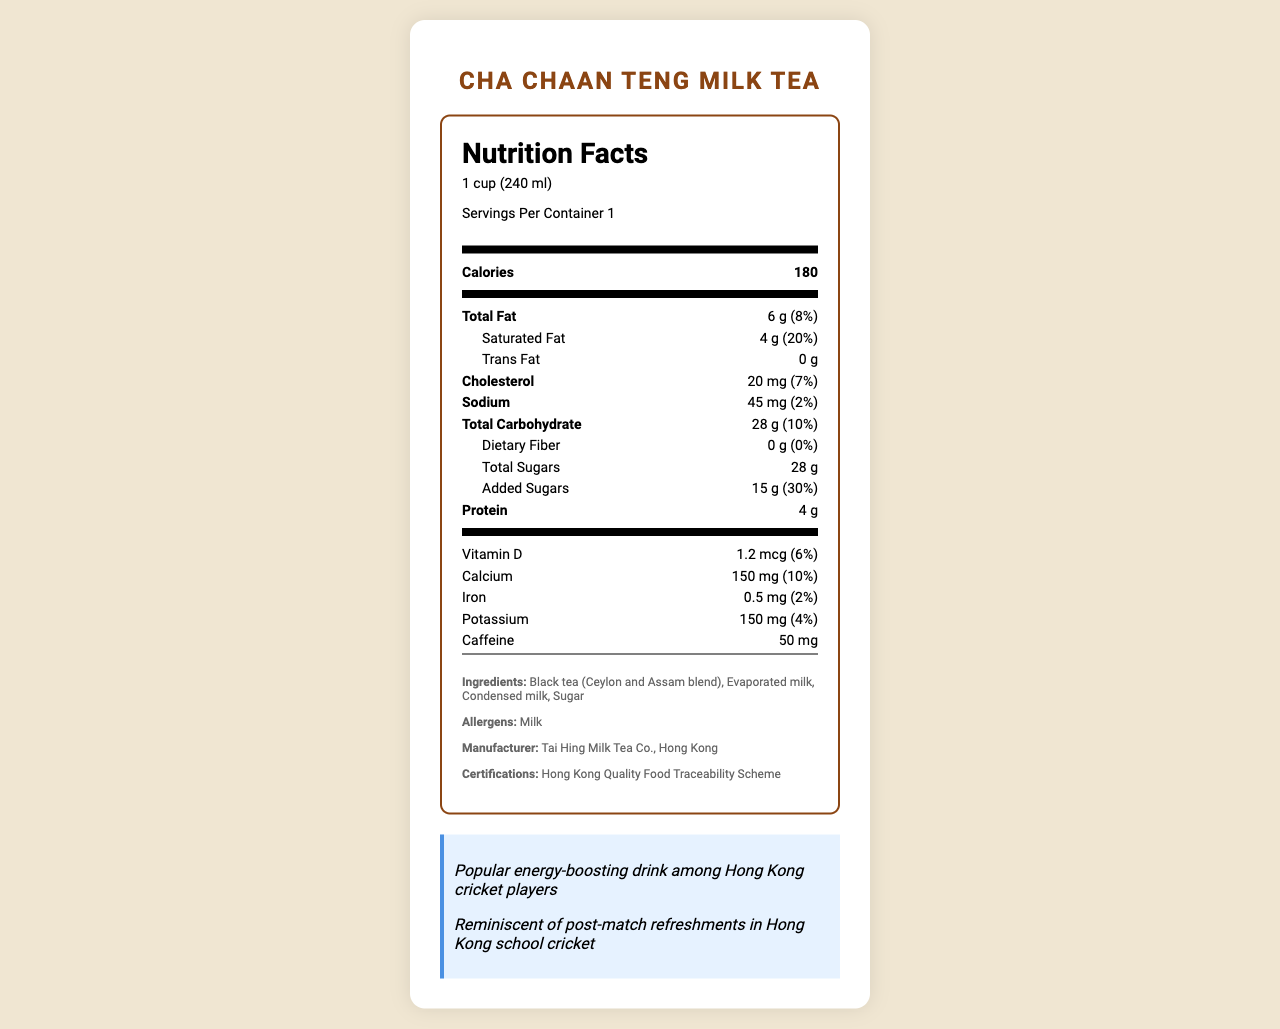what is the serving size of the Cha Chaan Teng Milk Tea? The serving size is displayed right under the product name at the top of the nutrition label.
Answer: 1 cup (240 ml) how many calories are there per serving? The number of calories per serving is listed in bold directly below the serving information.
Answer: 180 what percentage of the daily value does the Total Fat content represent? Below the Total Fat amount of 6 g, the percentage daily value is given as 8%.
Answer: 8% what is the amount of added sugars per serving? The amount of added sugars is listed as 15 g in the indentation under Total Sugars.
Answer: 15 g what is the potassium content in milligrams? The potassium content is stated as 150 mg with a 4% daily value on the label.
Answer: 150 mg which ingredient is listed first in the milk tea? The ingredient list starts with "Black tea (Ceylon and Assam blend)" indicating it is the first and major ingredient.
Answer: Black tea (Ceylon and Assam blend) what certification does the product have? A. ISO 9001 B. FDA Approved C. Hong Kong Quality Food Traceability Scheme D. Organic Certified The certifications section lists "Hong Kong Quality Food Traceability Scheme."
Answer: C. Hong Kong Quality Food Traceability Scheme how much caffeine does one serving contain? The caffeine content is indicated as 50 mg at the bottom of the nutrition information panel.
Answer: 50 mg is this product suitable for someone with a milk allergy? The allergens section clearly states "Milk," hence it is not suitable for someone with a milk allergy.
Answer: No how much saturated fat is in one serving, and what percentage of the daily value does it represent? The nutrition label specifies that Saturated Fat is 4 g and its daily value percentage is 20%.
Answer: 4 g, 20% what amount of Vitamin D does one serving contain? A. 0.5 mcg B. 1.2 mcg C. 10 mg D. 2.0 mg The nutrition label lists Vitamin D content as 1.2 mcg.
Answer: B. 1.2 mcg is the total carbohydrate amount higher or lower than the protein amount in one serving? The total carbohydrate amount is 28 g, whereas the protein amount is 4 g.
Answer: Higher what preparation method is noted for its unique texture? The additional info mentions that the traditional "silk stocking" method is used for a smooth texture.
Answer: Traditional 'silk stocking' method summarize the main idea of the document The document is a detailed nutrition label for Cha Chaan Teng Milk Tea, featuring serving size, calorie content, nutritional values, and additional details like ingredients, allergens, manufacturer, and cultural notes.
Answer: The document provides the nutrition facts for Cha Chaan Teng Milk Tea, including serving size, calorie content, and detailed nutritional information. It highlights popular features among Hong Kong cricket players and provides additional cultural significance and preparation details. what is the name of the manufacturer? The additional information section lists the manufacturer as Tai Hing Milk Tea Co., Hong Kong.
Answer: Tai Hing Milk Tea Co., Hong Kong what is the sodium percentage of the daily value, and how much does one serving contribute to it? The nutrition label states that the sodium amount for one serving is 45 mg, which contributes to 2% of the daily value.
Answer: 2% does the document specify the source country of the tea blend used? The document mentions "Black tea (Ceylon and Assam blend)" but does not specify the source country of the tea in the ingredients.
Answer: No 